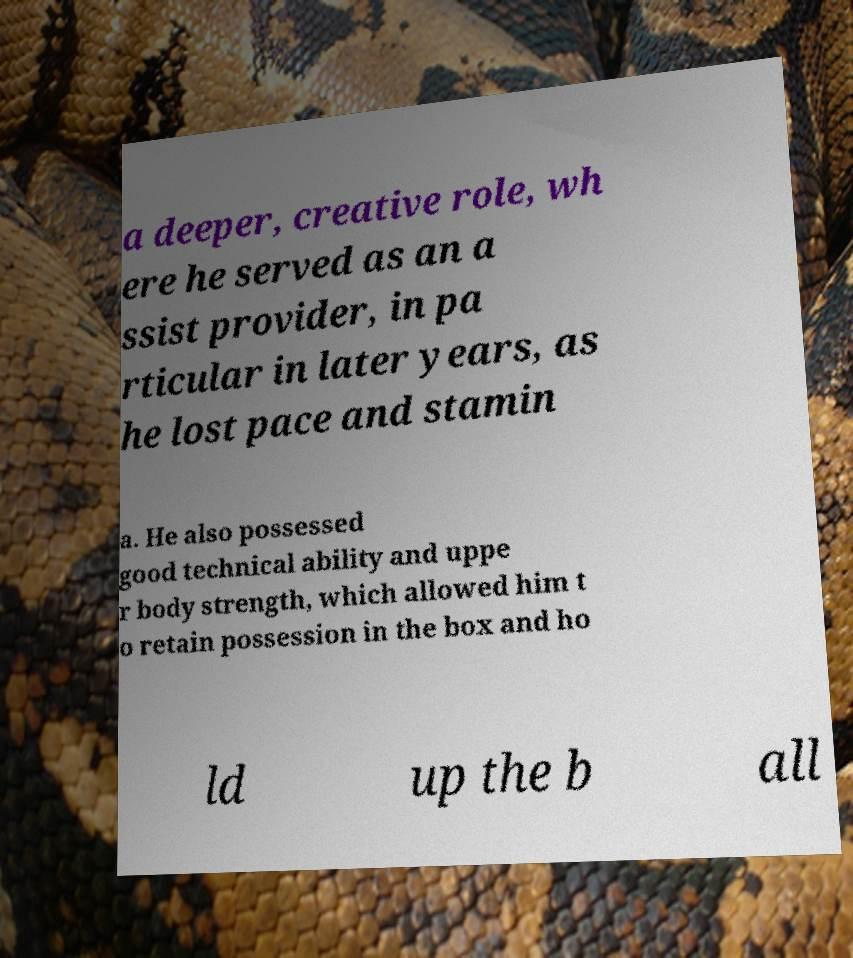There's text embedded in this image that I need extracted. Can you transcribe it verbatim? a deeper, creative role, wh ere he served as an a ssist provider, in pa rticular in later years, as he lost pace and stamin a. He also possessed good technical ability and uppe r body strength, which allowed him t o retain possession in the box and ho ld up the b all 